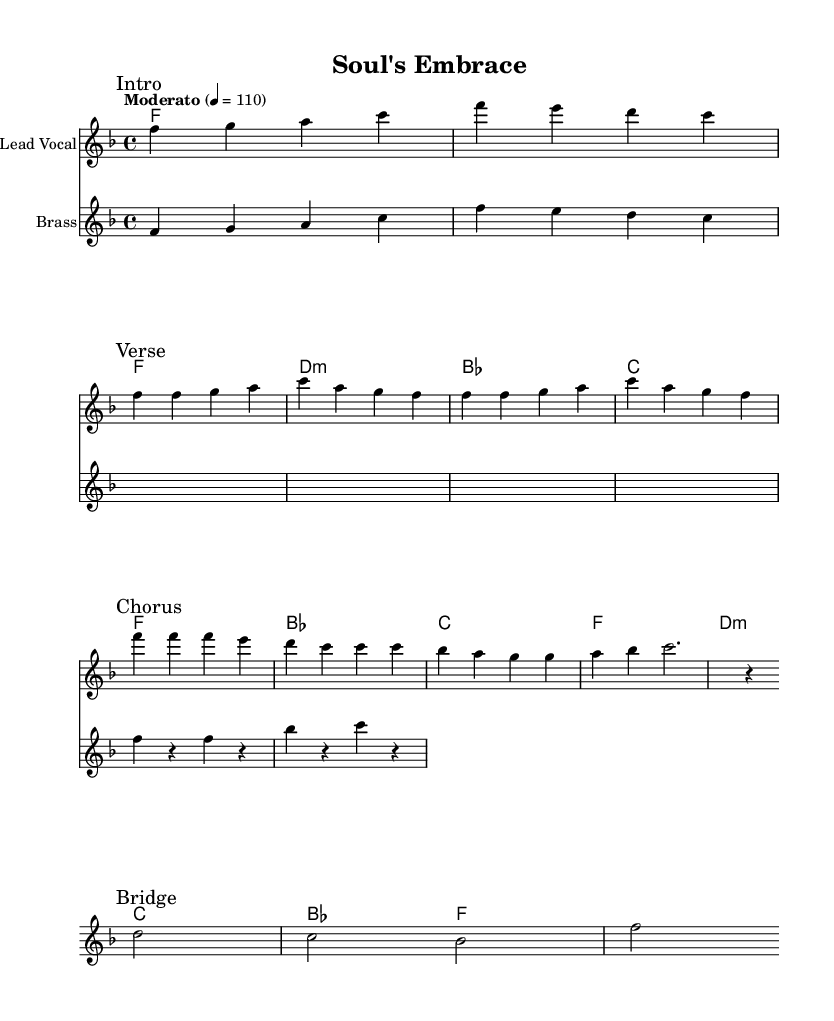What is the key signature of this music? The key signature is F major, which has one flat (B flat). This can be determined from the key signature indicated at the beginning of the score.
Answer: F major What is the time signature of the piece? The time signature is 4/4, as shown at the start of the score. It indicates that there are four beats in each measure and the quarter note gets one beat.
Answer: 4/4 What is the tempo marking? The tempo marking is "Moderato" at a speed of 110 beats per minute, which indicates a moderate pace for the piece. This is specified in the tempo directive at the beginning of the score.
Answer: Moderato 110 How many measures are in the chorus section? The chorus consists of four measures as indicated in the marked "Chorus" section, which includes the corresponding notes and rests.
Answer: 4 measures What chord follows the first F chord in the chord progression? The chord following the first F chord is a D minor chord, as seen in the chord symbols listed in the harmony section of the sheet music.
Answer: D minor What type of brass instrumentation is indicated in the score? The score specifies "Brass" as the instrument for the second staff, which typically includes various brass instruments that would perform the written section. However, the specific type is not detailed in the score.
Answer: Brass How many distinct sections are noted in the composition? There are four distinct sections noted: Intro, Verse, Chorus, and Bridge. Each section is marked clearly in the score to denote different parts of the song.
Answer: 4 sections 